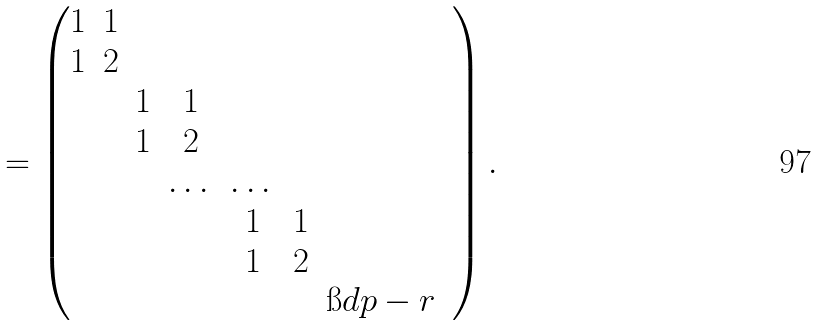Convert formula to latex. <formula><loc_0><loc_0><loc_500><loc_500>= \begin{pmatrix} 1 & 1 & & & & & & \\ 1 & 2 & & & & & & \\ & & 1 & 1 & & & & \\ & & 1 & 2 & & & & \\ & & & \dots & \dots & & \\ & & & & 1 & 1 & & \\ & & & & 1 & 2 & & \\ & & & & & & \i d { p - r } \end{pmatrix} .</formula> 